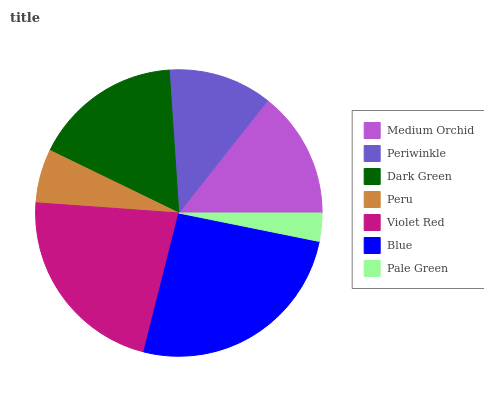Is Pale Green the minimum?
Answer yes or no. Yes. Is Blue the maximum?
Answer yes or no. Yes. Is Periwinkle the minimum?
Answer yes or no. No. Is Periwinkle the maximum?
Answer yes or no. No. Is Medium Orchid greater than Periwinkle?
Answer yes or no. Yes. Is Periwinkle less than Medium Orchid?
Answer yes or no. Yes. Is Periwinkle greater than Medium Orchid?
Answer yes or no. No. Is Medium Orchid less than Periwinkle?
Answer yes or no. No. Is Medium Orchid the high median?
Answer yes or no. Yes. Is Medium Orchid the low median?
Answer yes or no. Yes. Is Periwinkle the high median?
Answer yes or no. No. Is Pale Green the low median?
Answer yes or no. No. 